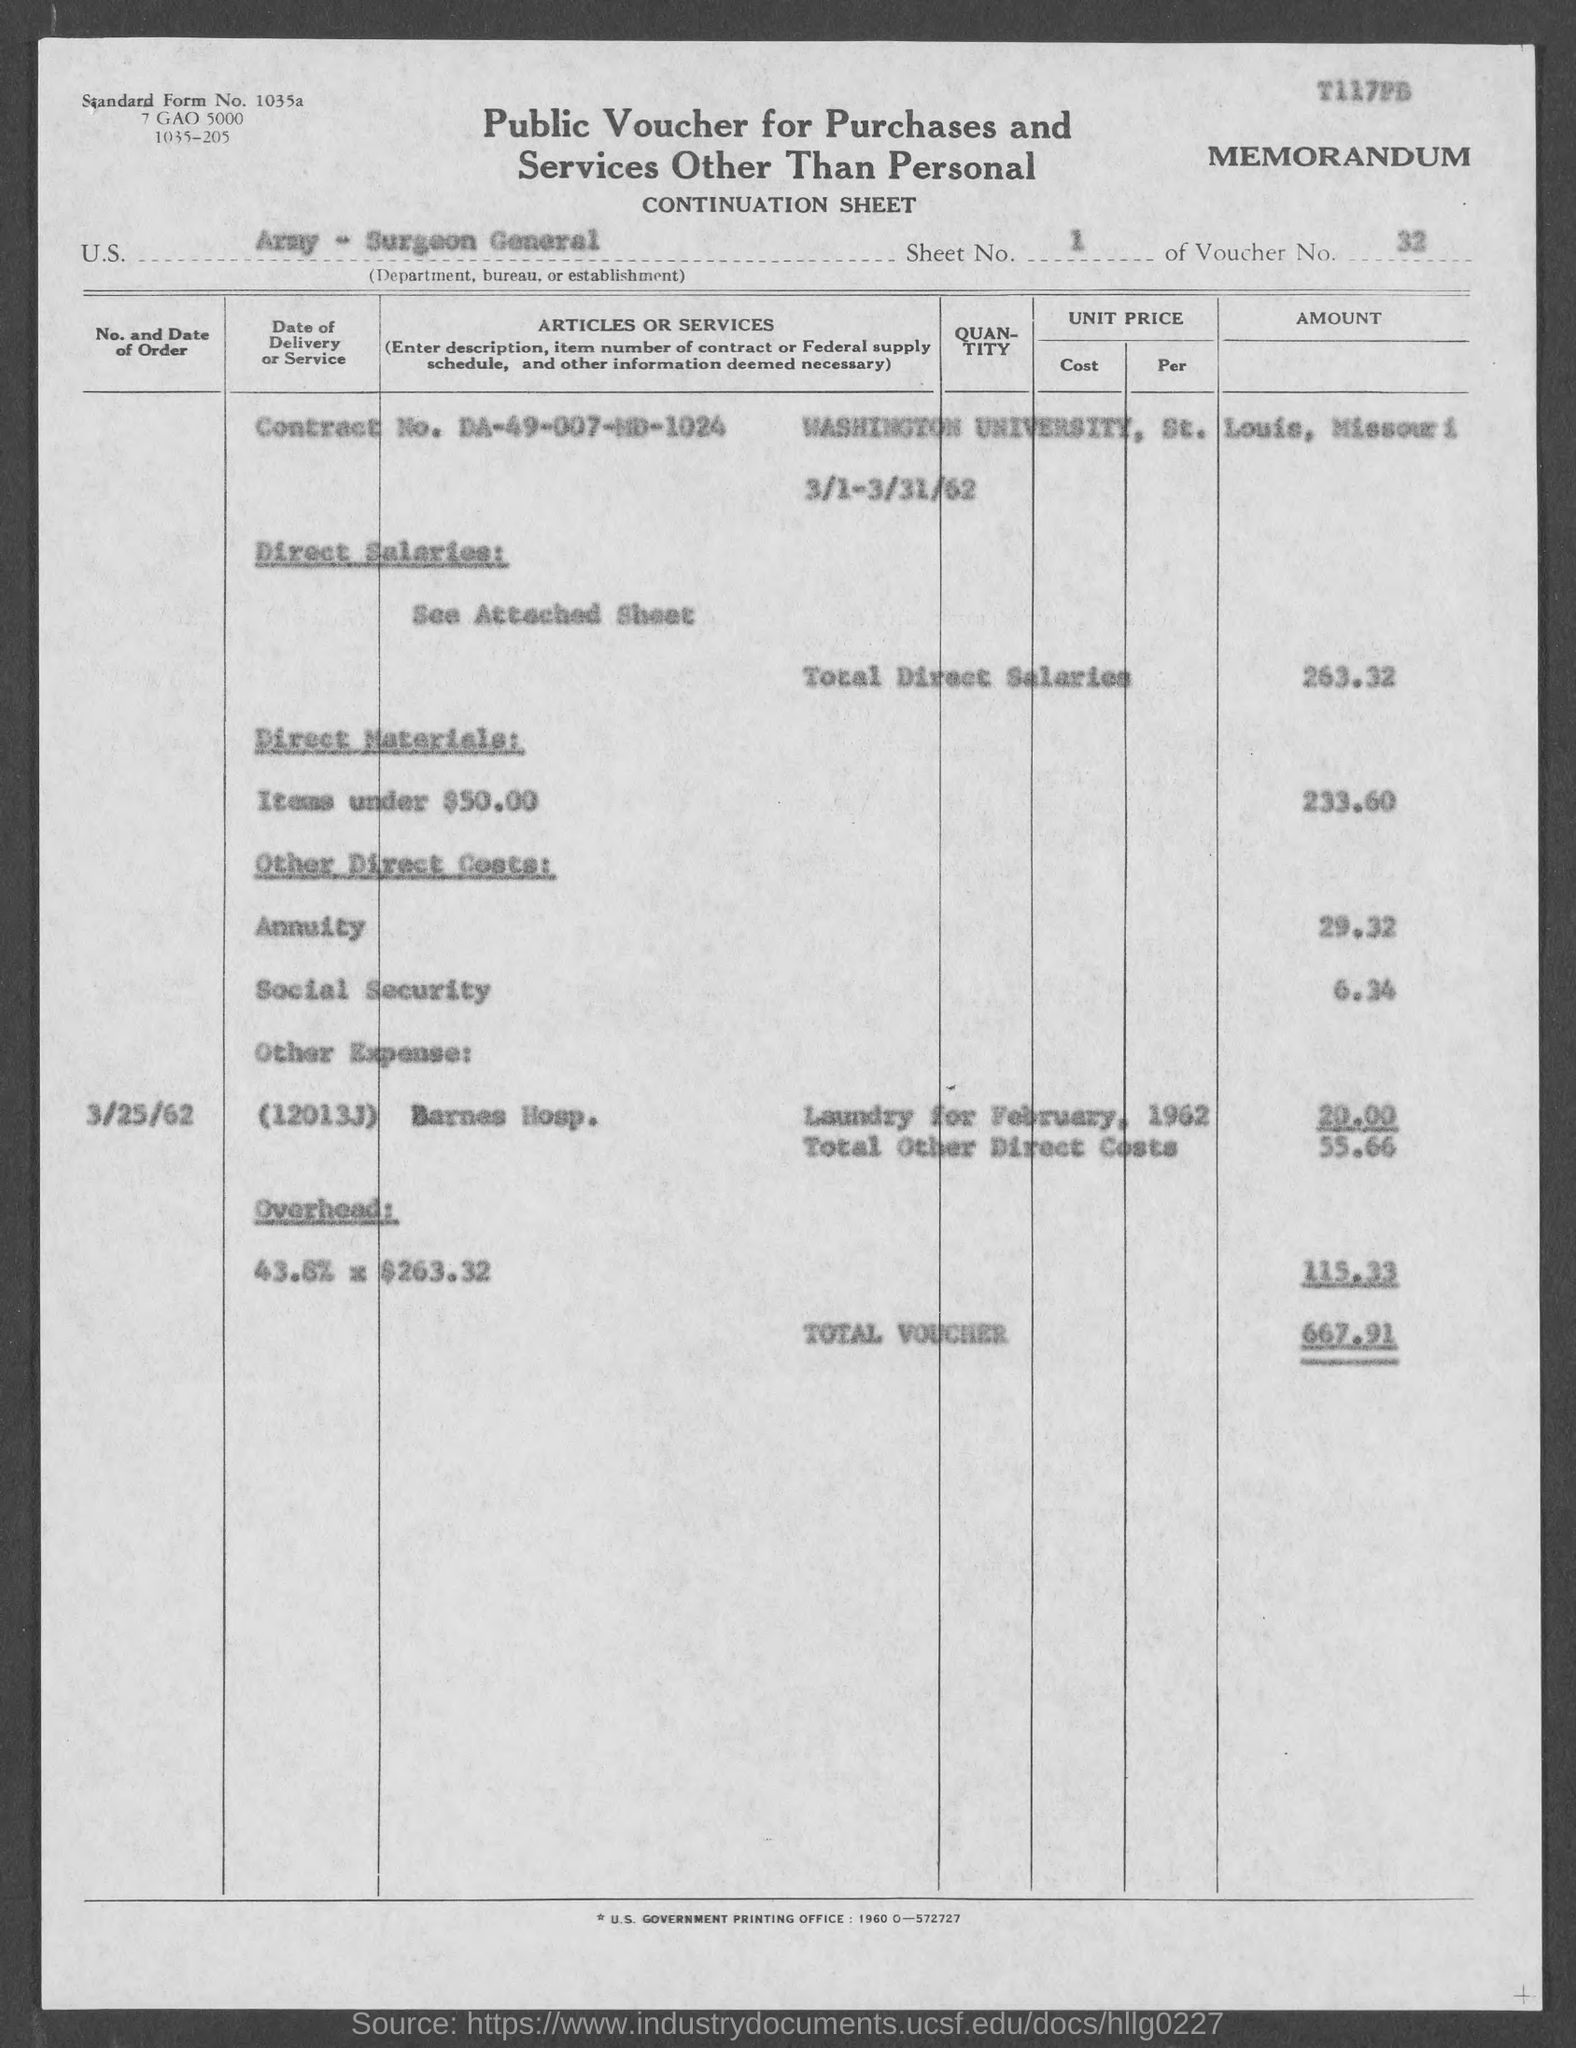Can you tell me more about the direct salaries mentioned in the document? The document lists the total direct salaries as $263.32. This likely represents compensation for specific services or labor provided over a period, possibly related to a project or clinical operation at Washington University, St. Louis. 